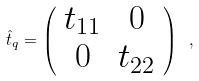Convert formula to latex. <formula><loc_0><loc_0><loc_500><loc_500>\hat { t } _ { q } = \left ( \begin{array} { c c } t _ { 1 1 } & 0 \\ 0 & t _ { 2 2 } \end{array} \right ) \ ,</formula> 